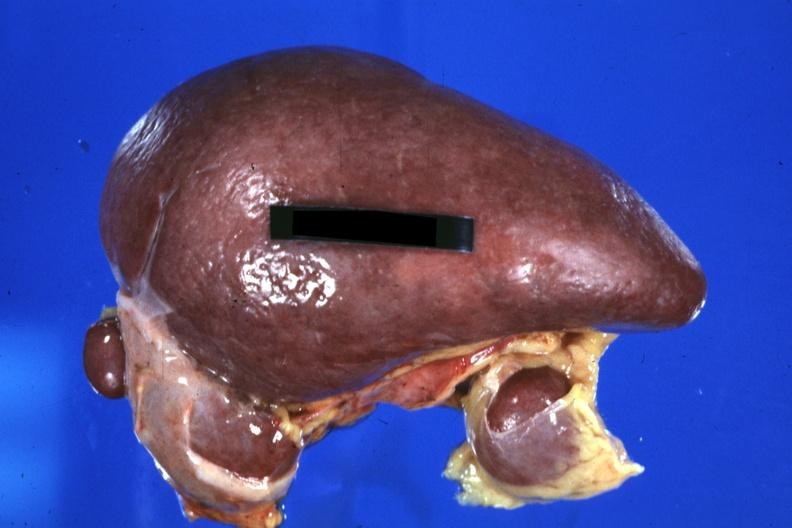how does this image show spleen?
Answer the question using a single word or phrase. With three accessories 32yobf left isomerism and complex congenital heart disease 